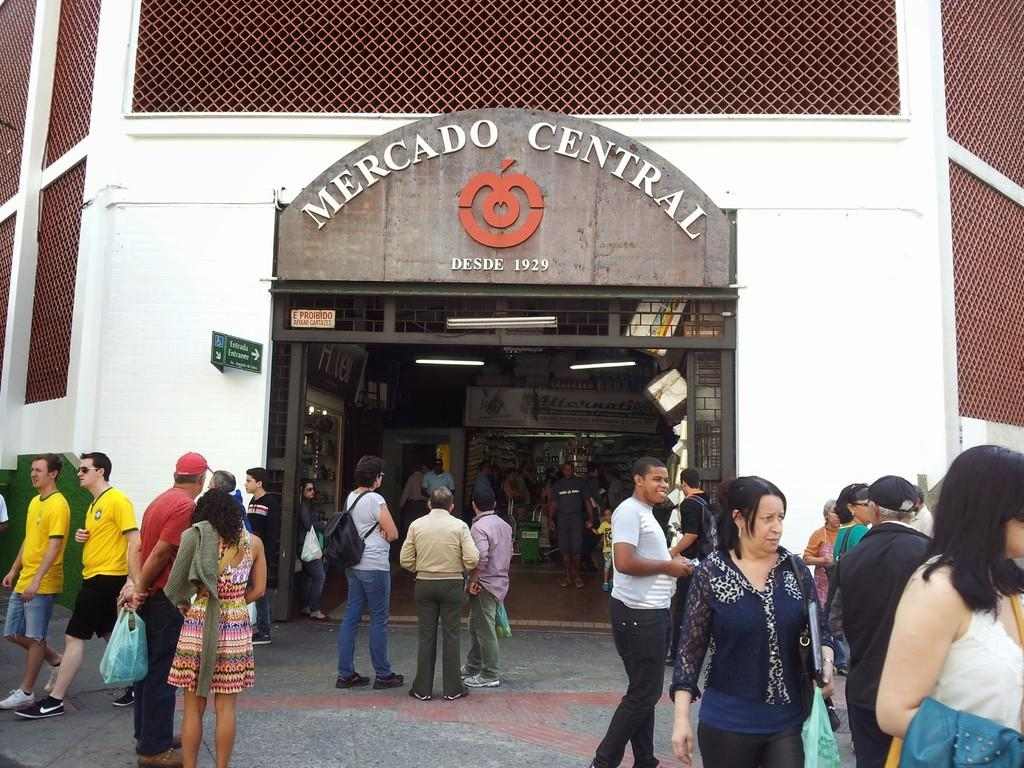<image>
Create a compact narrative representing the image presented. people outside a shopping market place called Mercado Central 